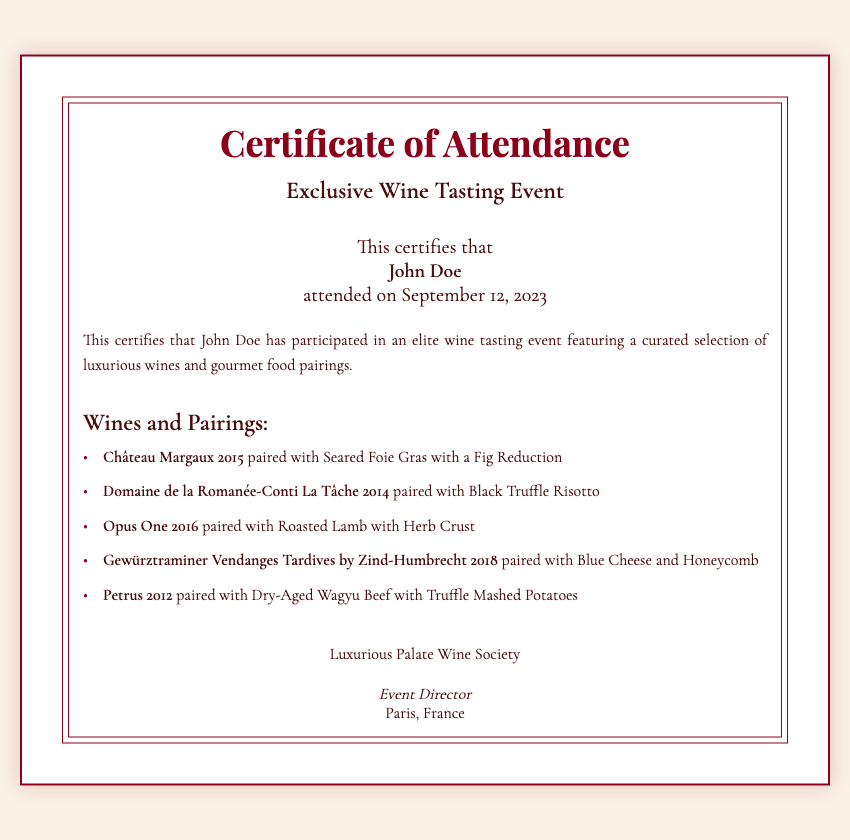What is the title of the certificate? The title of the certificate is prominently displayed at the top of the document.
Answer: Certificate of Attendance Who attended the event? The name of the participant is stated in the certificate, confirming their attendance.
Answer: John Doe When did the event take place? The date of the event is mentioned right below the participant's name.
Answer: September 12, 2023 What wine was paired with the Seared Foie Gras? The pairing for Seared Foie Gras is listed under the wines and pairings section.
Answer: Château Margaux 2015 How many wines are sampled in the event? The number of wines sampled can be determined by counting the number of wine items in the document.
Answer: Five Which wine paired with Roasted Lamb? The document lists specific wines paired with gourmet foods.
Answer: Opus One 2016 What is the name of the wine society? The name of the organization associated with the event is located in the footer of the document.
Answer: Luxurious Palate Wine Society Who is the event director? The event director's title is indicated in the footer, beneath the society's name.
Answer: Event Director Where was the event held? The location of the event is indicated at the bottom of the document.
Answer: Paris, France 